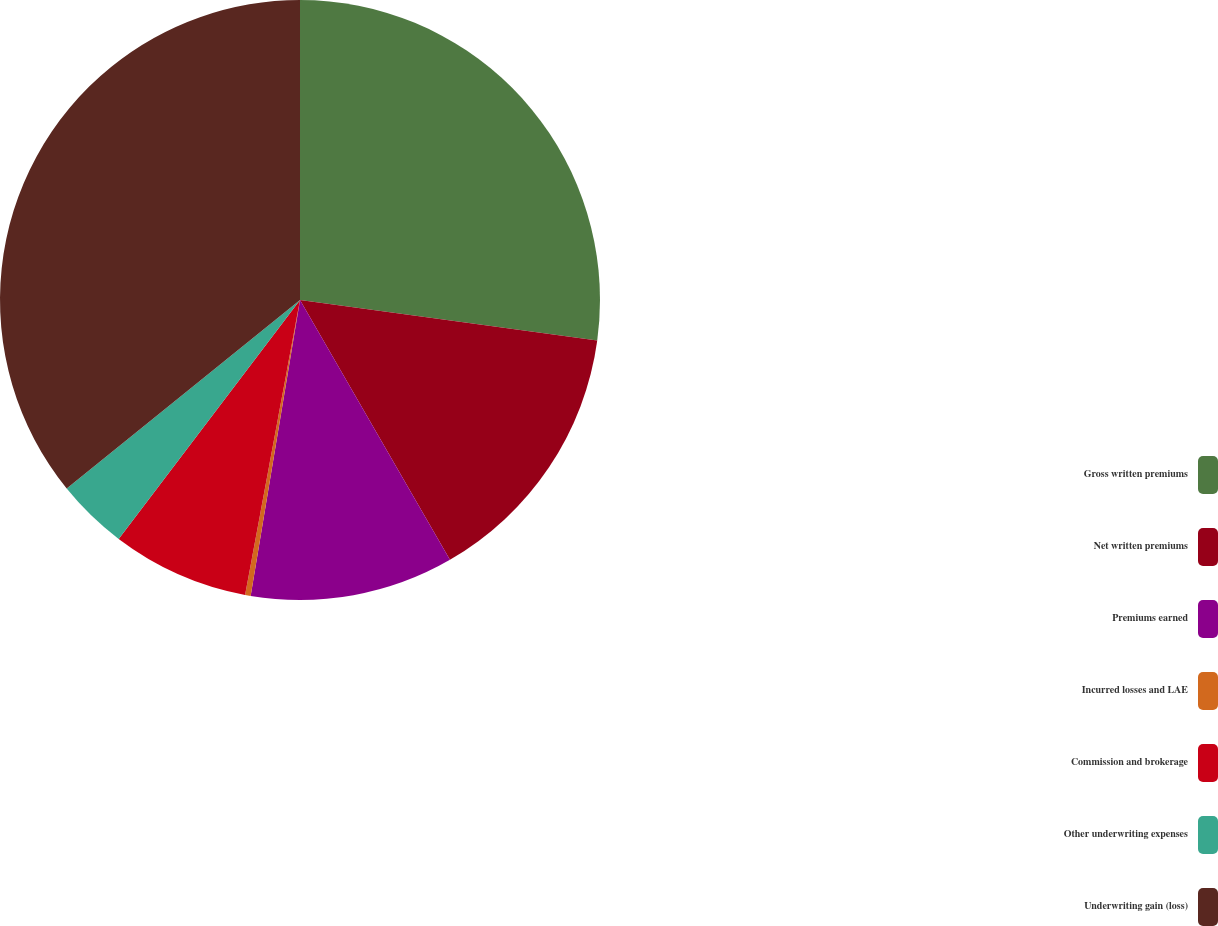Convert chart to OTSL. <chart><loc_0><loc_0><loc_500><loc_500><pie_chart><fcel>Gross written premiums<fcel>Net written premiums<fcel>Premiums earned<fcel>Incurred losses and LAE<fcel>Commission and brokerage<fcel>Other underwriting expenses<fcel>Underwriting gain (loss)<nl><fcel>27.16%<fcel>14.51%<fcel>10.96%<fcel>0.3%<fcel>7.4%<fcel>3.85%<fcel>35.82%<nl></chart> 